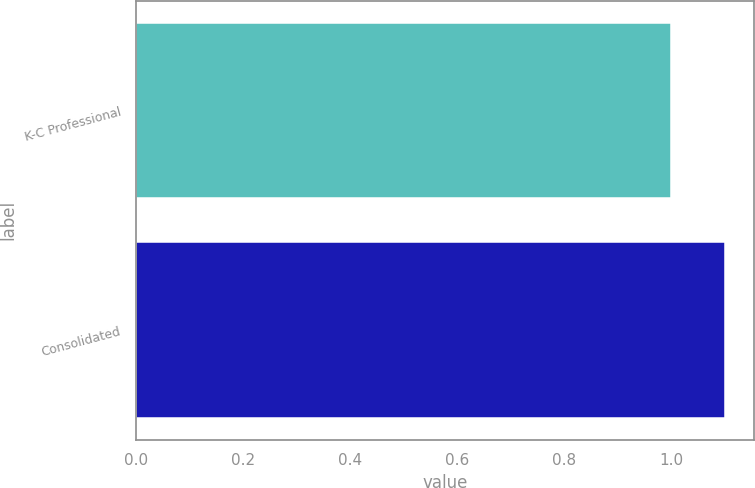Convert chart. <chart><loc_0><loc_0><loc_500><loc_500><bar_chart><fcel>K-C Professional<fcel>Consolidated<nl><fcel>1<fcel>1.1<nl></chart> 